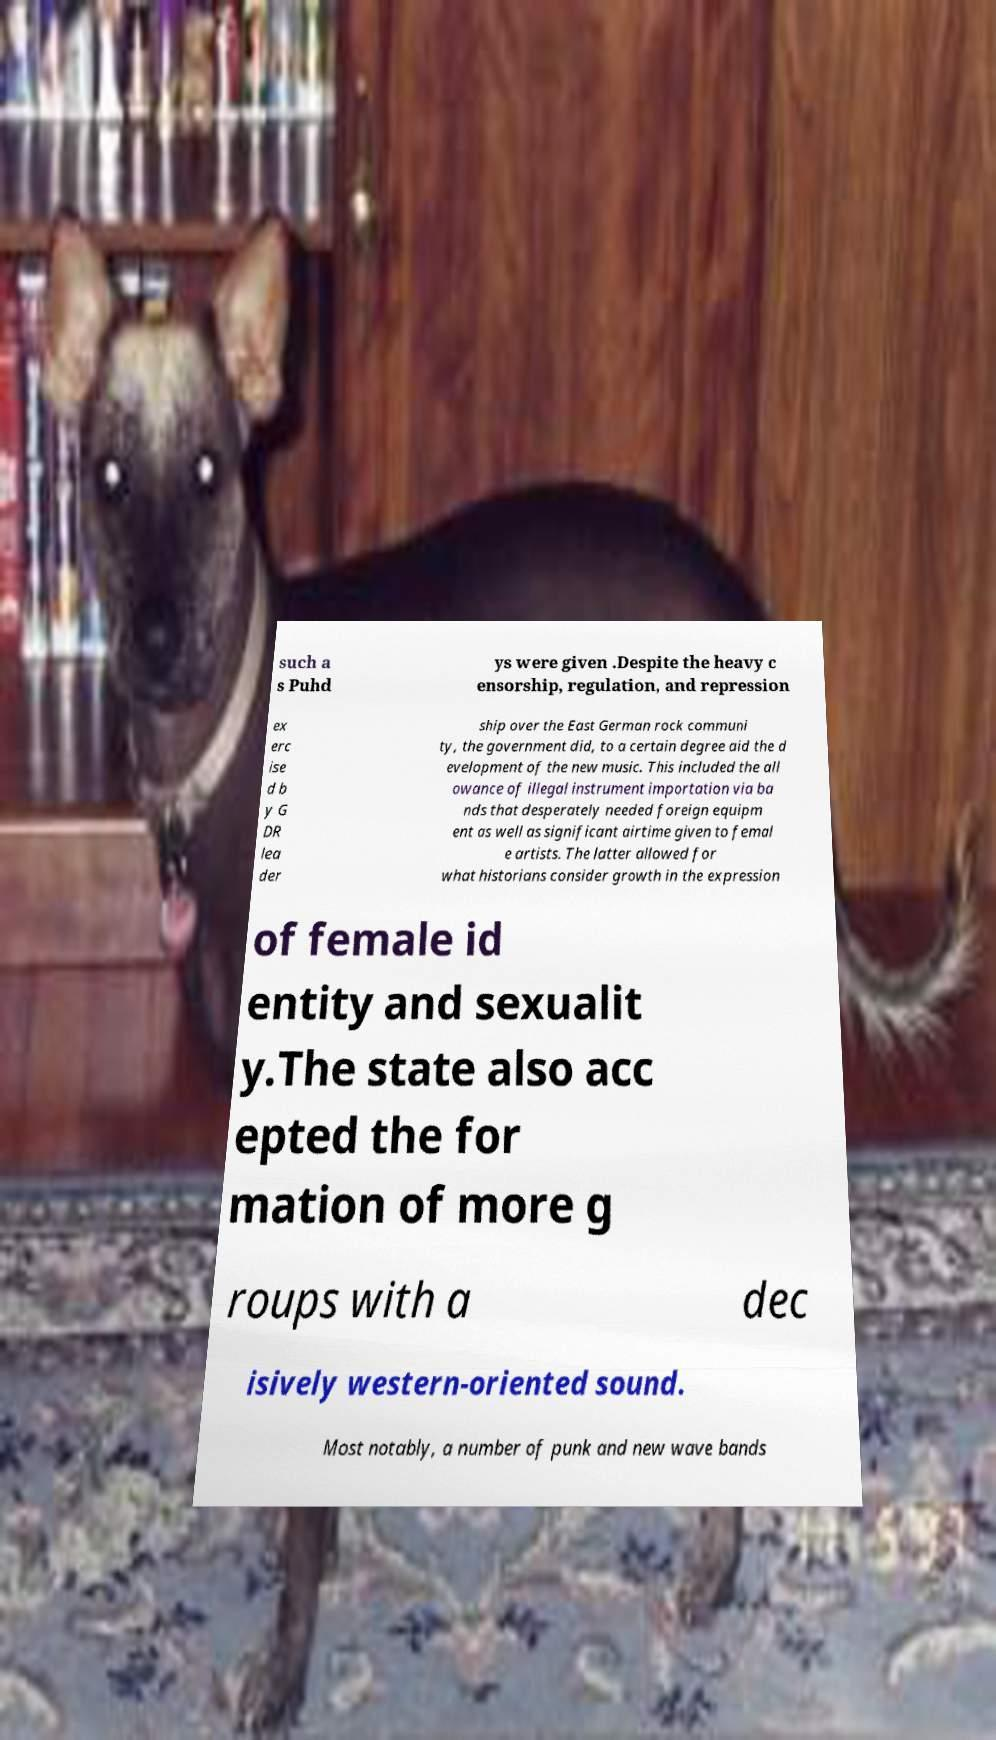Could you assist in decoding the text presented in this image and type it out clearly? such a s Puhd ys were given .Despite the heavy c ensorship, regulation, and repression ex erc ise d b y G DR lea der ship over the East German rock communi ty, the government did, to a certain degree aid the d evelopment of the new music. This included the all owance of illegal instrument importation via ba nds that desperately needed foreign equipm ent as well as significant airtime given to femal e artists. The latter allowed for what historians consider growth in the expression of female id entity and sexualit y.The state also acc epted the for mation of more g roups with a dec isively western-oriented sound. Most notably, a number of punk and new wave bands 